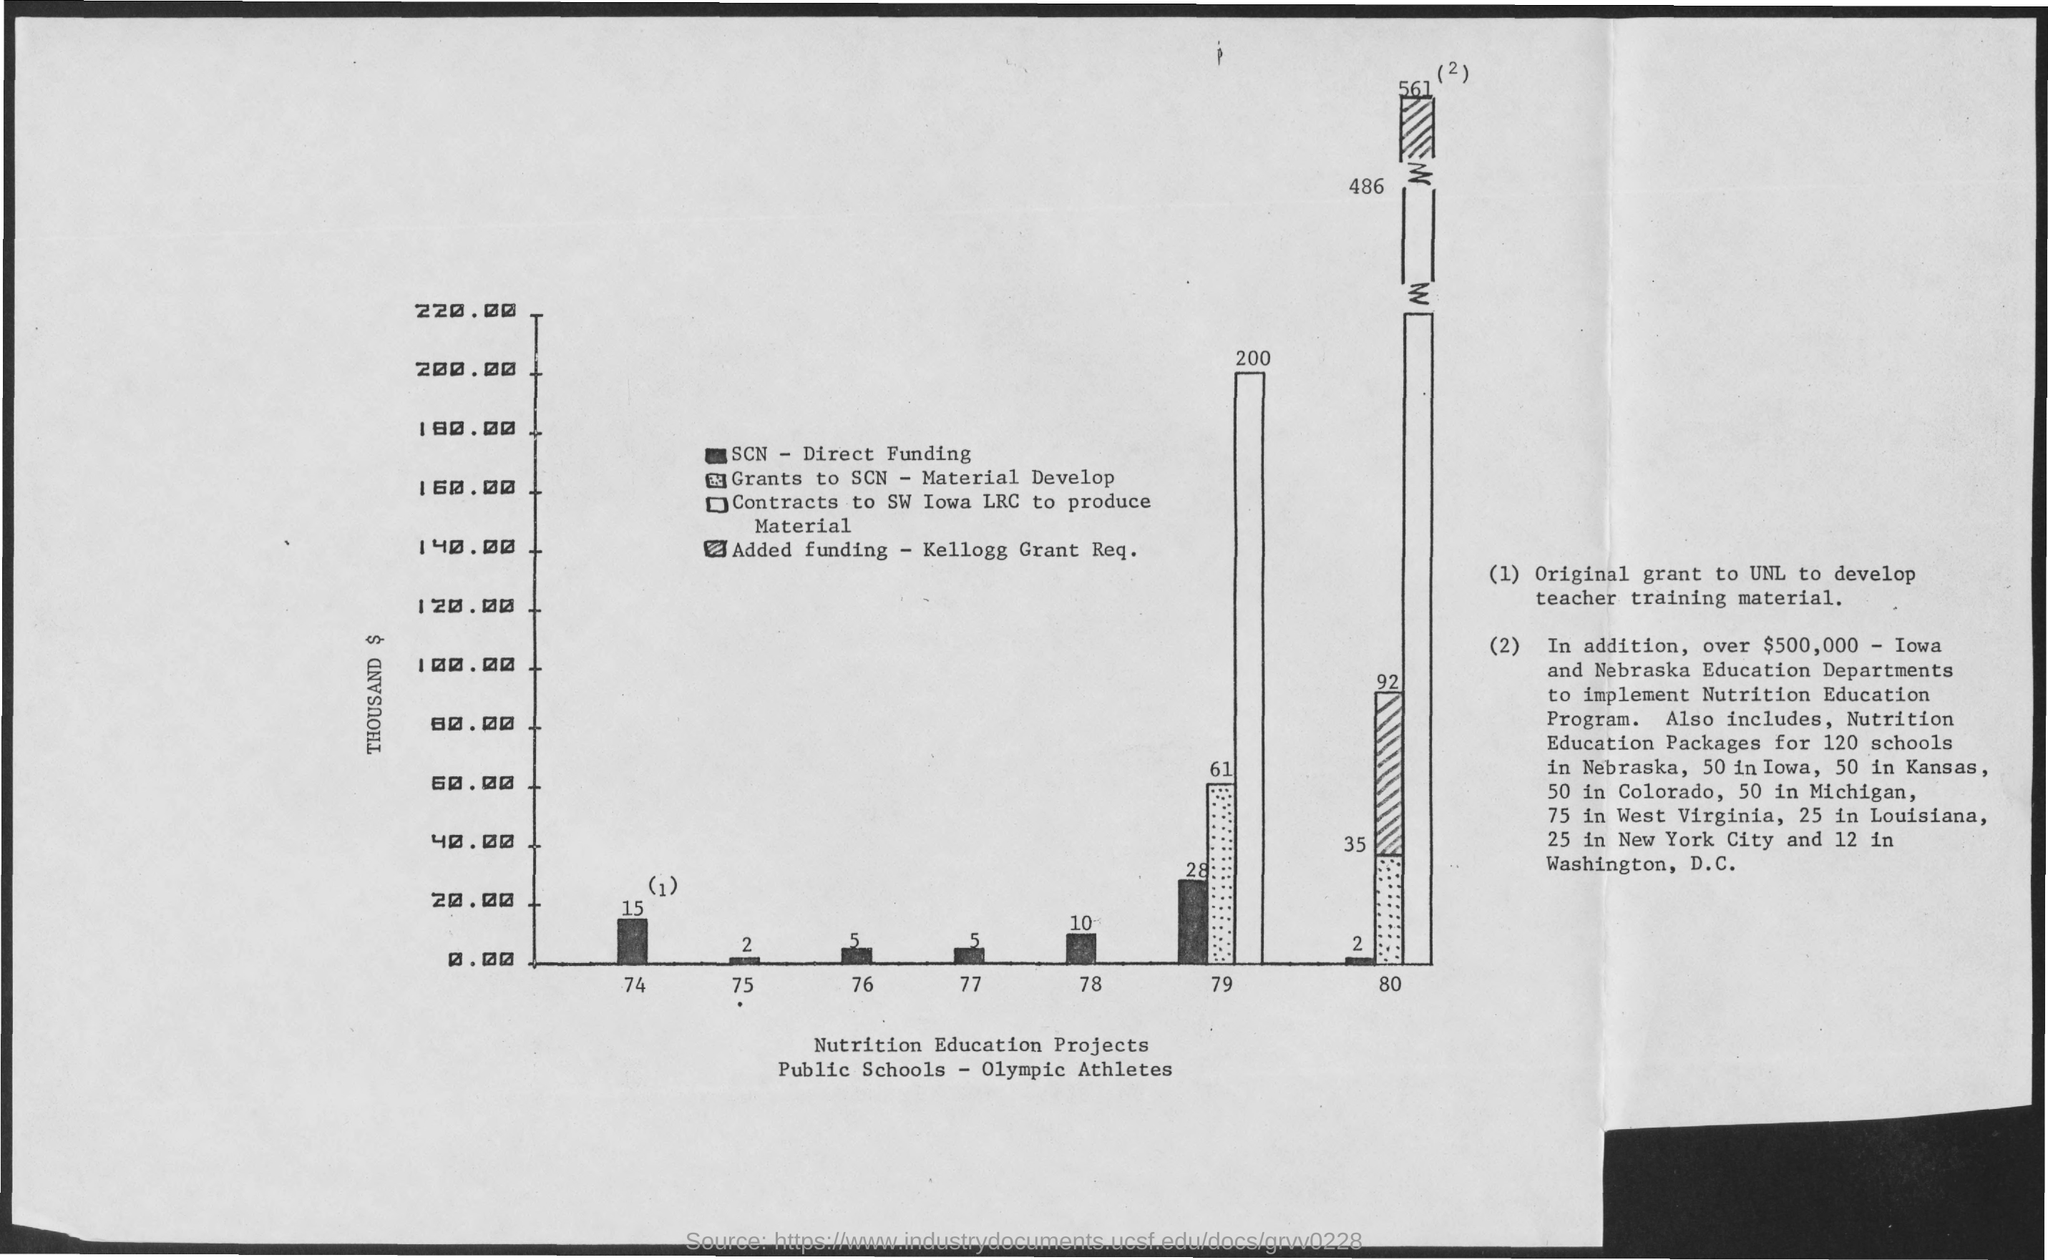Mention a couple of crucial points in this snapshot. The amount of SCN Direct funding in 77 is $5,000. The total amount given for contracts to the Southwest Iowa Local Rural Community (LRC) to produce materials in 1979 was $200,000. The SCN - Direct Funding amount in 1974 was $15,000. The SCN - Direct Funding amount in 1977 was 5,000 dollars. In 1979, the total amount granted to SCN for material development was $61,000. 